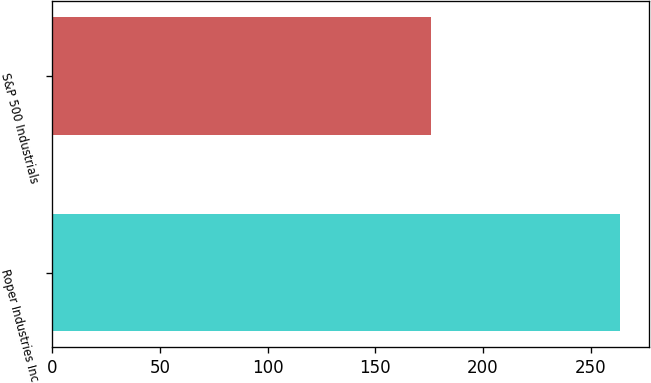Convert chart. <chart><loc_0><loc_0><loc_500><loc_500><bar_chart><fcel>Roper Industries Inc<fcel>S&P 500 Industrials<nl><fcel>263.76<fcel>175.73<nl></chart> 